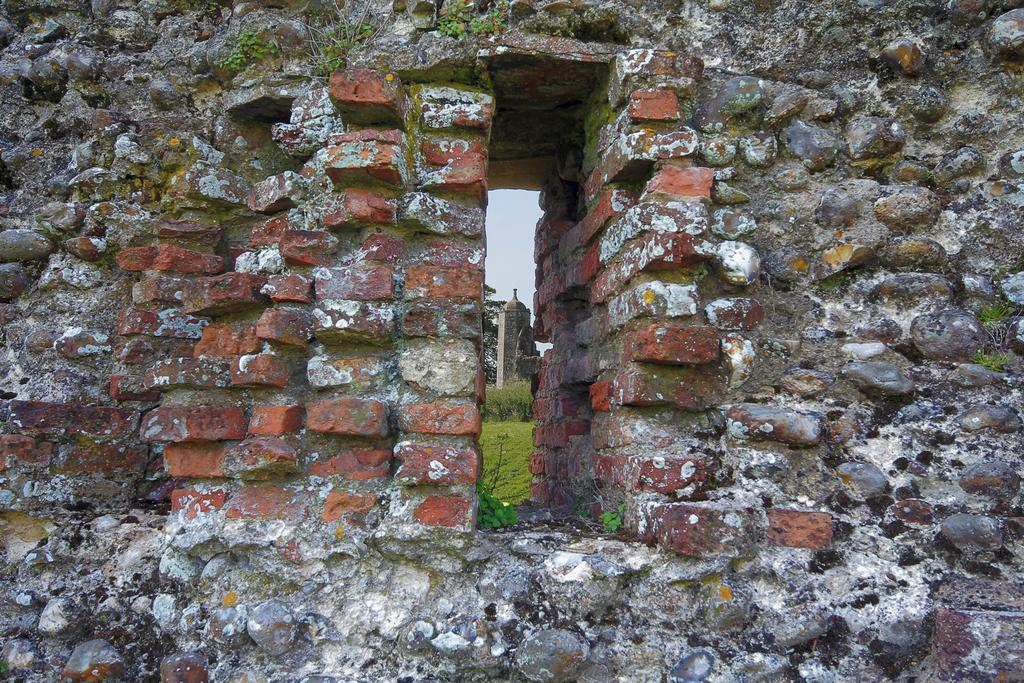What is present in the image that separates the foreground from the background? There is a wall in the image. What feature is present in the wall? There is a hole in the center of the wall. What can be seen in the distance behind the wall? There is a tower visible in the background of the image. What else is visible in the background of the image? The sky and trees are visible in the background of the image. What hobbies do the trees in the background of the image enjoy? Trees do not have hobbies, as they are inanimate objects. 